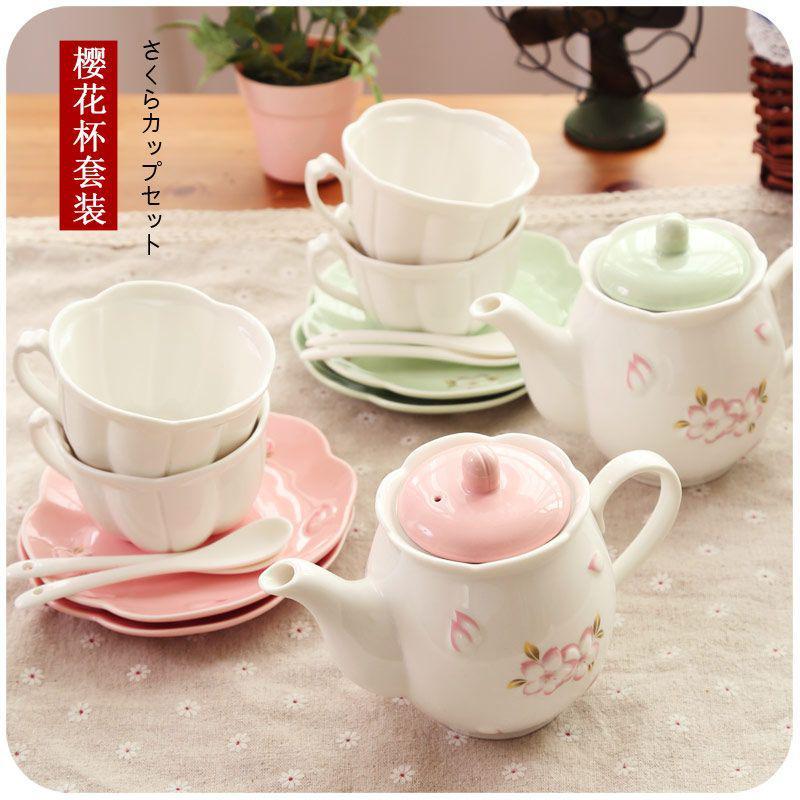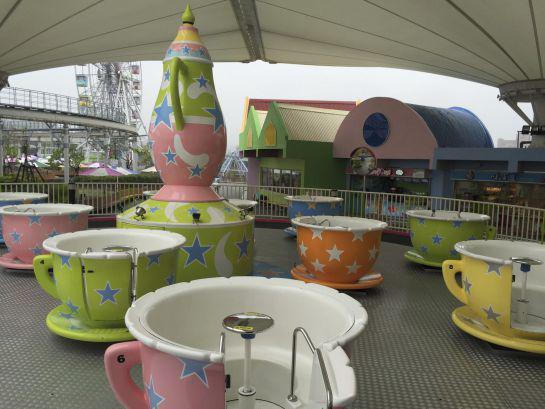The first image is the image on the left, the second image is the image on the right. Given the left and right images, does the statement "Some cups are solid colored." hold true? Answer yes or no. Yes. The first image is the image on the left, the second image is the image on the right. Given the left and right images, does the statement "In at least one image there are five coffee cups and in the there there is a tea kettle." hold true? Answer yes or no. No. 